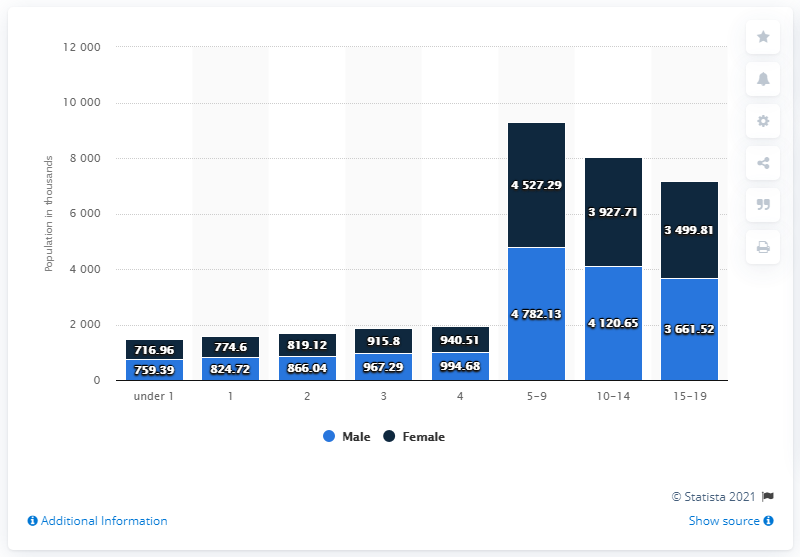List a handful of essential elements in this visual. The lowest value in the blue bar is 759.39. The sum of the highest and lowest values of the blue bar is 5541.52. 